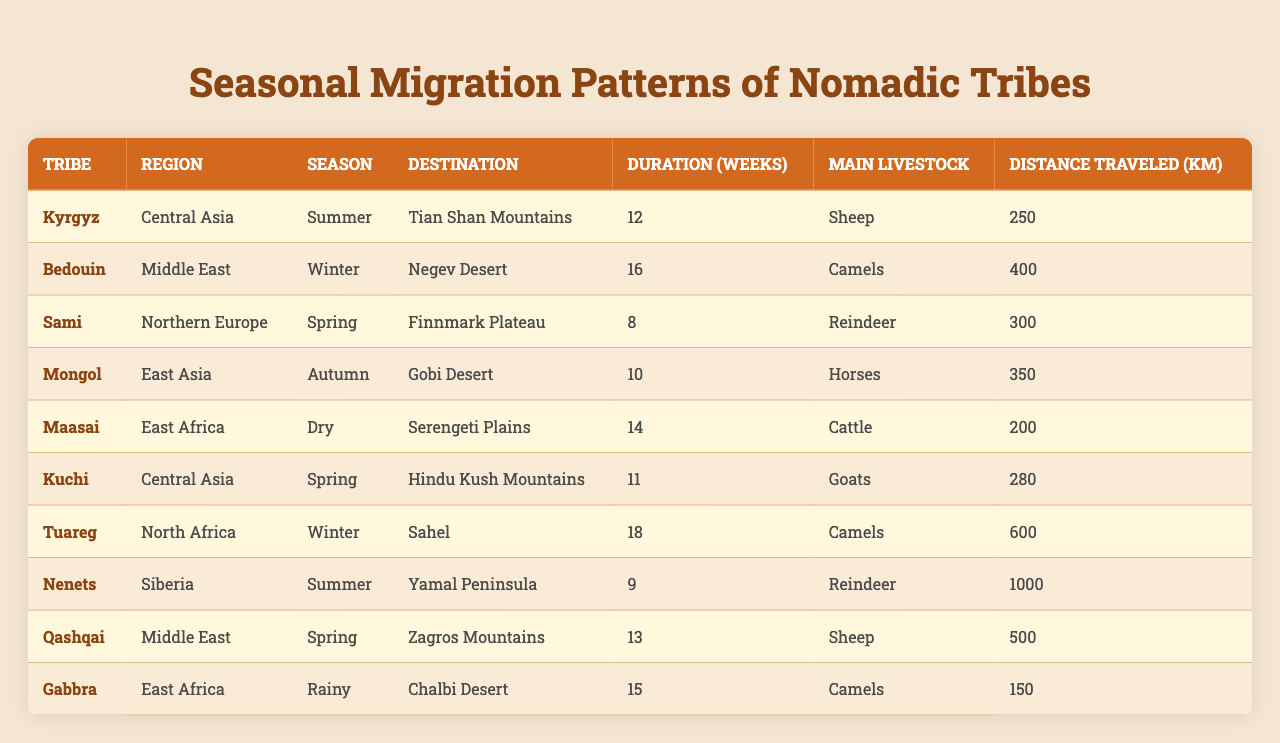What is the main livestock of the Nenets tribe? The table shows that the main livestock of the Nenets tribe is reindeer.
Answer: Reindeer How many weeks do the Tuareg spend migrating to the Sahel? According to the table, the Tuareg spend 18 weeks migrating to the Sahel.
Answer: 18 weeks Which tribe travels the shortest distance during their migration, and how far is it? The table indicates that the Gabbra tribe travels the shortest distance, which is 150 km to the Chalbi Desert.
Answer: Gabbra, 150 km What is the total distance traveled by the Kyrgyz and Kuchi tribes combined? The Kyrgyz travel 250 km and the Kuchi travel 280 km. Adding these gives a total of 250 + 280 = 530 km.
Answer: 530 km In which season do the Maasai migrate, and to where? The table states that the Maasai migrate during the dry season to the Serengeti Plains.
Answer: Dry season, Serengeti Plains Is it true that the Mongol tribe travels more than 300 km during their migration? Yes, the table shows that the Mongol tribe travels 350 km, which is indeed more than 300 km.
Answer: True Which tribe has the longest migration duration, and what is that duration? The Tuareg tribe has the longest migration duration of 18 weeks according to the table.
Answer: Tuareg, 18 weeks If you were to calculate the average duration of migration for all tribes listed, what would it be? The total duration is 12 + 16 + 8 + 10 + 14 + 11 + 18 + 9 + 13 + 15 =  136 weeks for 10 tribes, so the average is 136 / 10 = 13.6 weeks.
Answer: 13.6 weeks How many tribes migrate during the winter season? The table shows that there are two tribes (Bedouin and Tuareg) migrating during the winter season.
Answer: 2 tribes Which tribe travels the farthest, and what distance do they cover? The Nenets tribe travels the farthest, covering a distance of 1000 km to the Yamal Peninsula.
Answer: Nenets, 1000 km 